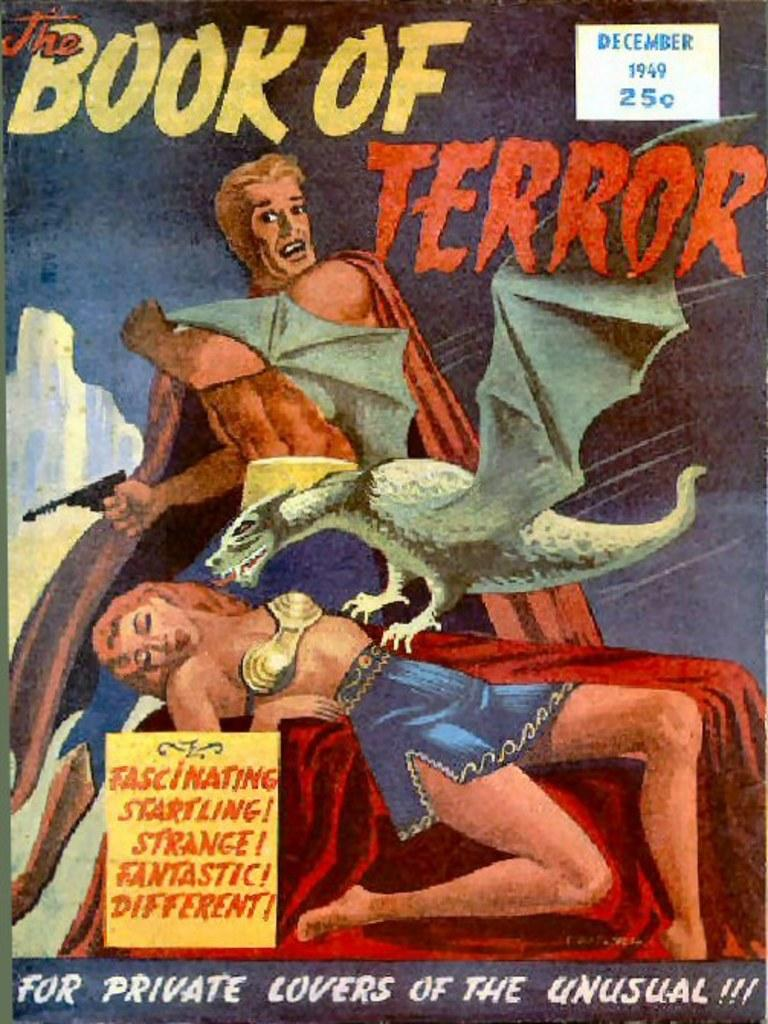What is the main subject of the poster in the image? The poster contains images of a man, a woman, and a dragon. What type of creature is depicted on the poster? The poster contains an image of a dragon. Are there any people depicted on the poster? Yes, there are images of a man and a woman on the poster. Is there any text on the poster? Yes, there is text on the poster. What type of silverware is visible in the image? There is no silverware present in the image. Can you describe the garden featured in the image? There is no garden present in the image. 